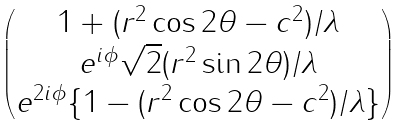<formula> <loc_0><loc_0><loc_500><loc_500>\begin{pmatrix} 1 + ( r ^ { 2 } \cos 2 \theta - c ^ { 2 } ) / \lambda \\ e ^ { i \phi } \sqrt { 2 } ( r ^ { 2 } \sin 2 \theta ) / \lambda \\ e ^ { 2 i \phi } \{ 1 - ( r ^ { 2 } \cos 2 \theta - c ^ { 2 } ) / \lambda \} \end{pmatrix}</formula> 